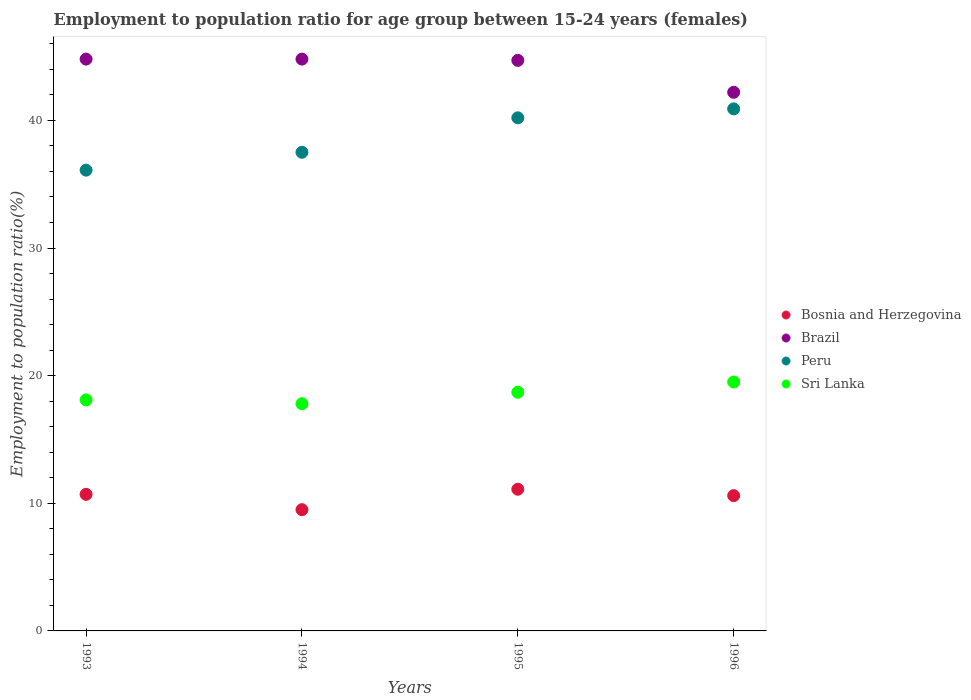What is the employment to population ratio in Sri Lanka in 1994?
Your answer should be compact. 17.8. Across all years, what is the maximum employment to population ratio in Peru?
Keep it short and to the point. 40.9. Across all years, what is the minimum employment to population ratio in Sri Lanka?
Your answer should be very brief. 17.8. In which year was the employment to population ratio in Bosnia and Herzegovina maximum?
Your response must be concise. 1995. In which year was the employment to population ratio in Sri Lanka minimum?
Your answer should be compact. 1994. What is the total employment to population ratio in Peru in the graph?
Your answer should be compact. 154.7. What is the difference between the employment to population ratio in Brazil in 1994 and that in 1995?
Ensure brevity in your answer.  0.1. What is the average employment to population ratio in Brazil per year?
Give a very brief answer. 44.12. In the year 1993, what is the difference between the employment to population ratio in Bosnia and Herzegovina and employment to population ratio in Peru?
Give a very brief answer. -25.4. In how many years, is the employment to population ratio in Peru greater than 42 %?
Keep it short and to the point. 0. What is the ratio of the employment to population ratio in Peru in 1993 to that in 1996?
Give a very brief answer. 0.88. Is the difference between the employment to population ratio in Bosnia and Herzegovina in 1993 and 1996 greater than the difference between the employment to population ratio in Peru in 1993 and 1996?
Give a very brief answer. Yes. What is the difference between the highest and the second highest employment to population ratio in Peru?
Keep it short and to the point. 0.7. What is the difference between the highest and the lowest employment to population ratio in Sri Lanka?
Offer a terse response. 1.7. Is the sum of the employment to population ratio in Peru in 1993 and 1994 greater than the maximum employment to population ratio in Brazil across all years?
Offer a terse response. Yes. Is it the case that in every year, the sum of the employment to population ratio in Bosnia and Herzegovina and employment to population ratio in Peru  is greater than the sum of employment to population ratio in Brazil and employment to population ratio in Sri Lanka?
Offer a terse response. No. Does the employment to population ratio in Sri Lanka monotonically increase over the years?
Provide a short and direct response. No. Is the employment to population ratio in Brazil strictly greater than the employment to population ratio in Peru over the years?
Provide a short and direct response. Yes. Is the employment to population ratio in Bosnia and Herzegovina strictly less than the employment to population ratio in Peru over the years?
Give a very brief answer. Yes. How many dotlines are there?
Provide a short and direct response. 4. How many years are there in the graph?
Offer a terse response. 4. What is the difference between two consecutive major ticks on the Y-axis?
Make the answer very short. 10. Are the values on the major ticks of Y-axis written in scientific E-notation?
Offer a terse response. No. Does the graph contain grids?
Offer a terse response. No. Where does the legend appear in the graph?
Your answer should be compact. Center right. What is the title of the graph?
Offer a terse response. Employment to population ratio for age group between 15-24 years (females). Does "OECD members" appear as one of the legend labels in the graph?
Your answer should be very brief. No. What is the label or title of the X-axis?
Your answer should be compact. Years. What is the label or title of the Y-axis?
Give a very brief answer. Employment to population ratio(%). What is the Employment to population ratio(%) of Bosnia and Herzegovina in 1993?
Offer a very short reply. 10.7. What is the Employment to population ratio(%) in Brazil in 1993?
Give a very brief answer. 44.8. What is the Employment to population ratio(%) of Peru in 1993?
Your answer should be very brief. 36.1. What is the Employment to population ratio(%) in Sri Lanka in 1993?
Provide a succinct answer. 18.1. What is the Employment to population ratio(%) of Bosnia and Herzegovina in 1994?
Offer a very short reply. 9.5. What is the Employment to population ratio(%) of Brazil in 1994?
Offer a terse response. 44.8. What is the Employment to population ratio(%) of Peru in 1994?
Offer a very short reply. 37.5. What is the Employment to population ratio(%) of Sri Lanka in 1994?
Keep it short and to the point. 17.8. What is the Employment to population ratio(%) in Bosnia and Herzegovina in 1995?
Your answer should be very brief. 11.1. What is the Employment to population ratio(%) in Brazil in 1995?
Keep it short and to the point. 44.7. What is the Employment to population ratio(%) of Peru in 1995?
Provide a short and direct response. 40.2. What is the Employment to population ratio(%) of Sri Lanka in 1995?
Ensure brevity in your answer.  18.7. What is the Employment to population ratio(%) of Bosnia and Herzegovina in 1996?
Your response must be concise. 10.6. What is the Employment to population ratio(%) of Brazil in 1996?
Provide a short and direct response. 42.2. What is the Employment to population ratio(%) of Peru in 1996?
Ensure brevity in your answer.  40.9. Across all years, what is the maximum Employment to population ratio(%) of Bosnia and Herzegovina?
Make the answer very short. 11.1. Across all years, what is the maximum Employment to population ratio(%) of Brazil?
Your response must be concise. 44.8. Across all years, what is the maximum Employment to population ratio(%) of Peru?
Make the answer very short. 40.9. Across all years, what is the maximum Employment to population ratio(%) in Sri Lanka?
Provide a short and direct response. 19.5. Across all years, what is the minimum Employment to population ratio(%) in Bosnia and Herzegovina?
Your answer should be compact. 9.5. Across all years, what is the minimum Employment to population ratio(%) in Brazil?
Offer a terse response. 42.2. Across all years, what is the minimum Employment to population ratio(%) in Peru?
Keep it short and to the point. 36.1. Across all years, what is the minimum Employment to population ratio(%) of Sri Lanka?
Make the answer very short. 17.8. What is the total Employment to population ratio(%) in Bosnia and Herzegovina in the graph?
Provide a short and direct response. 41.9. What is the total Employment to population ratio(%) of Brazil in the graph?
Make the answer very short. 176.5. What is the total Employment to population ratio(%) in Peru in the graph?
Your response must be concise. 154.7. What is the total Employment to population ratio(%) in Sri Lanka in the graph?
Give a very brief answer. 74.1. What is the difference between the Employment to population ratio(%) in Bosnia and Herzegovina in 1993 and that in 1994?
Keep it short and to the point. 1.2. What is the difference between the Employment to population ratio(%) in Brazil in 1993 and that in 1994?
Ensure brevity in your answer.  0. What is the difference between the Employment to population ratio(%) in Peru in 1993 and that in 1994?
Your answer should be very brief. -1.4. What is the difference between the Employment to population ratio(%) in Sri Lanka in 1993 and that in 1994?
Give a very brief answer. 0.3. What is the difference between the Employment to population ratio(%) of Bosnia and Herzegovina in 1993 and that in 1995?
Your response must be concise. -0.4. What is the difference between the Employment to population ratio(%) in Brazil in 1993 and that in 1995?
Offer a terse response. 0.1. What is the difference between the Employment to population ratio(%) of Bosnia and Herzegovina in 1993 and that in 1996?
Make the answer very short. 0.1. What is the difference between the Employment to population ratio(%) in Brazil in 1993 and that in 1996?
Give a very brief answer. 2.6. What is the difference between the Employment to population ratio(%) in Sri Lanka in 1993 and that in 1996?
Your answer should be very brief. -1.4. What is the difference between the Employment to population ratio(%) of Bosnia and Herzegovina in 1994 and that in 1995?
Offer a terse response. -1.6. What is the difference between the Employment to population ratio(%) in Brazil in 1994 and that in 1995?
Provide a short and direct response. 0.1. What is the difference between the Employment to population ratio(%) of Peru in 1994 and that in 1995?
Offer a very short reply. -2.7. What is the difference between the Employment to population ratio(%) in Sri Lanka in 1994 and that in 1995?
Give a very brief answer. -0.9. What is the difference between the Employment to population ratio(%) in Bosnia and Herzegovina in 1994 and that in 1996?
Keep it short and to the point. -1.1. What is the difference between the Employment to population ratio(%) in Brazil in 1994 and that in 1996?
Provide a succinct answer. 2.6. What is the difference between the Employment to population ratio(%) of Bosnia and Herzegovina in 1995 and that in 1996?
Make the answer very short. 0.5. What is the difference between the Employment to population ratio(%) of Brazil in 1995 and that in 1996?
Give a very brief answer. 2.5. What is the difference between the Employment to population ratio(%) of Bosnia and Herzegovina in 1993 and the Employment to population ratio(%) of Brazil in 1994?
Your answer should be very brief. -34.1. What is the difference between the Employment to population ratio(%) of Bosnia and Herzegovina in 1993 and the Employment to population ratio(%) of Peru in 1994?
Your answer should be compact. -26.8. What is the difference between the Employment to population ratio(%) of Bosnia and Herzegovina in 1993 and the Employment to population ratio(%) of Sri Lanka in 1994?
Give a very brief answer. -7.1. What is the difference between the Employment to population ratio(%) of Brazil in 1993 and the Employment to population ratio(%) of Peru in 1994?
Make the answer very short. 7.3. What is the difference between the Employment to population ratio(%) in Peru in 1993 and the Employment to population ratio(%) in Sri Lanka in 1994?
Offer a very short reply. 18.3. What is the difference between the Employment to population ratio(%) of Bosnia and Herzegovina in 1993 and the Employment to population ratio(%) of Brazil in 1995?
Offer a very short reply. -34. What is the difference between the Employment to population ratio(%) of Bosnia and Herzegovina in 1993 and the Employment to population ratio(%) of Peru in 1995?
Keep it short and to the point. -29.5. What is the difference between the Employment to population ratio(%) of Brazil in 1993 and the Employment to population ratio(%) of Peru in 1995?
Give a very brief answer. 4.6. What is the difference between the Employment to population ratio(%) in Brazil in 1993 and the Employment to population ratio(%) in Sri Lanka in 1995?
Ensure brevity in your answer.  26.1. What is the difference between the Employment to population ratio(%) of Peru in 1993 and the Employment to population ratio(%) of Sri Lanka in 1995?
Offer a terse response. 17.4. What is the difference between the Employment to population ratio(%) in Bosnia and Herzegovina in 1993 and the Employment to population ratio(%) in Brazil in 1996?
Make the answer very short. -31.5. What is the difference between the Employment to population ratio(%) of Bosnia and Herzegovina in 1993 and the Employment to population ratio(%) of Peru in 1996?
Make the answer very short. -30.2. What is the difference between the Employment to population ratio(%) of Brazil in 1993 and the Employment to population ratio(%) of Peru in 1996?
Your answer should be compact. 3.9. What is the difference between the Employment to population ratio(%) of Brazil in 1993 and the Employment to population ratio(%) of Sri Lanka in 1996?
Your response must be concise. 25.3. What is the difference between the Employment to population ratio(%) in Peru in 1993 and the Employment to population ratio(%) in Sri Lanka in 1996?
Offer a terse response. 16.6. What is the difference between the Employment to population ratio(%) of Bosnia and Herzegovina in 1994 and the Employment to population ratio(%) of Brazil in 1995?
Your answer should be very brief. -35.2. What is the difference between the Employment to population ratio(%) in Bosnia and Herzegovina in 1994 and the Employment to population ratio(%) in Peru in 1995?
Make the answer very short. -30.7. What is the difference between the Employment to population ratio(%) of Bosnia and Herzegovina in 1994 and the Employment to population ratio(%) of Sri Lanka in 1995?
Offer a terse response. -9.2. What is the difference between the Employment to population ratio(%) of Brazil in 1994 and the Employment to population ratio(%) of Sri Lanka in 1995?
Ensure brevity in your answer.  26.1. What is the difference between the Employment to population ratio(%) in Bosnia and Herzegovina in 1994 and the Employment to population ratio(%) in Brazil in 1996?
Provide a short and direct response. -32.7. What is the difference between the Employment to population ratio(%) of Bosnia and Herzegovina in 1994 and the Employment to population ratio(%) of Peru in 1996?
Your response must be concise. -31.4. What is the difference between the Employment to population ratio(%) in Brazil in 1994 and the Employment to population ratio(%) in Peru in 1996?
Ensure brevity in your answer.  3.9. What is the difference between the Employment to population ratio(%) in Brazil in 1994 and the Employment to population ratio(%) in Sri Lanka in 1996?
Your response must be concise. 25.3. What is the difference between the Employment to population ratio(%) of Bosnia and Herzegovina in 1995 and the Employment to population ratio(%) of Brazil in 1996?
Your response must be concise. -31.1. What is the difference between the Employment to population ratio(%) of Bosnia and Herzegovina in 1995 and the Employment to population ratio(%) of Peru in 1996?
Offer a very short reply. -29.8. What is the difference between the Employment to population ratio(%) in Brazil in 1995 and the Employment to population ratio(%) in Peru in 1996?
Your response must be concise. 3.8. What is the difference between the Employment to population ratio(%) of Brazil in 1995 and the Employment to population ratio(%) of Sri Lanka in 1996?
Provide a succinct answer. 25.2. What is the difference between the Employment to population ratio(%) in Peru in 1995 and the Employment to population ratio(%) in Sri Lanka in 1996?
Keep it short and to the point. 20.7. What is the average Employment to population ratio(%) in Bosnia and Herzegovina per year?
Make the answer very short. 10.47. What is the average Employment to population ratio(%) of Brazil per year?
Offer a terse response. 44.12. What is the average Employment to population ratio(%) in Peru per year?
Your answer should be compact. 38.67. What is the average Employment to population ratio(%) of Sri Lanka per year?
Provide a short and direct response. 18.52. In the year 1993, what is the difference between the Employment to population ratio(%) of Bosnia and Herzegovina and Employment to population ratio(%) of Brazil?
Provide a succinct answer. -34.1. In the year 1993, what is the difference between the Employment to population ratio(%) in Bosnia and Herzegovina and Employment to population ratio(%) in Peru?
Provide a short and direct response. -25.4. In the year 1993, what is the difference between the Employment to population ratio(%) of Brazil and Employment to population ratio(%) of Sri Lanka?
Offer a very short reply. 26.7. In the year 1993, what is the difference between the Employment to population ratio(%) in Peru and Employment to population ratio(%) in Sri Lanka?
Offer a terse response. 18. In the year 1994, what is the difference between the Employment to population ratio(%) of Bosnia and Herzegovina and Employment to population ratio(%) of Brazil?
Ensure brevity in your answer.  -35.3. In the year 1994, what is the difference between the Employment to population ratio(%) of Bosnia and Herzegovina and Employment to population ratio(%) of Peru?
Make the answer very short. -28. In the year 1994, what is the difference between the Employment to population ratio(%) of Bosnia and Herzegovina and Employment to population ratio(%) of Sri Lanka?
Provide a short and direct response. -8.3. In the year 1995, what is the difference between the Employment to population ratio(%) of Bosnia and Herzegovina and Employment to population ratio(%) of Brazil?
Your answer should be compact. -33.6. In the year 1995, what is the difference between the Employment to population ratio(%) of Bosnia and Herzegovina and Employment to population ratio(%) of Peru?
Your answer should be compact. -29.1. In the year 1995, what is the difference between the Employment to population ratio(%) in Brazil and Employment to population ratio(%) in Peru?
Offer a terse response. 4.5. In the year 1996, what is the difference between the Employment to population ratio(%) in Bosnia and Herzegovina and Employment to population ratio(%) in Brazil?
Offer a very short reply. -31.6. In the year 1996, what is the difference between the Employment to population ratio(%) in Bosnia and Herzegovina and Employment to population ratio(%) in Peru?
Provide a succinct answer. -30.3. In the year 1996, what is the difference between the Employment to population ratio(%) of Brazil and Employment to population ratio(%) of Sri Lanka?
Provide a short and direct response. 22.7. In the year 1996, what is the difference between the Employment to population ratio(%) of Peru and Employment to population ratio(%) of Sri Lanka?
Offer a terse response. 21.4. What is the ratio of the Employment to population ratio(%) in Bosnia and Herzegovina in 1993 to that in 1994?
Provide a succinct answer. 1.13. What is the ratio of the Employment to population ratio(%) in Peru in 1993 to that in 1994?
Give a very brief answer. 0.96. What is the ratio of the Employment to population ratio(%) in Sri Lanka in 1993 to that in 1994?
Your answer should be very brief. 1.02. What is the ratio of the Employment to population ratio(%) of Brazil in 1993 to that in 1995?
Offer a terse response. 1. What is the ratio of the Employment to population ratio(%) in Peru in 1993 to that in 1995?
Provide a succinct answer. 0.9. What is the ratio of the Employment to population ratio(%) of Sri Lanka in 1993 to that in 1995?
Your answer should be compact. 0.97. What is the ratio of the Employment to population ratio(%) in Bosnia and Herzegovina in 1993 to that in 1996?
Keep it short and to the point. 1.01. What is the ratio of the Employment to population ratio(%) in Brazil in 1993 to that in 1996?
Provide a succinct answer. 1.06. What is the ratio of the Employment to population ratio(%) of Peru in 1993 to that in 1996?
Provide a short and direct response. 0.88. What is the ratio of the Employment to population ratio(%) of Sri Lanka in 1993 to that in 1996?
Ensure brevity in your answer.  0.93. What is the ratio of the Employment to population ratio(%) of Bosnia and Herzegovina in 1994 to that in 1995?
Your answer should be compact. 0.86. What is the ratio of the Employment to population ratio(%) of Peru in 1994 to that in 1995?
Ensure brevity in your answer.  0.93. What is the ratio of the Employment to population ratio(%) in Sri Lanka in 1994 to that in 1995?
Ensure brevity in your answer.  0.95. What is the ratio of the Employment to population ratio(%) in Bosnia and Herzegovina in 1994 to that in 1996?
Give a very brief answer. 0.9. What is the ratio of the Employment to population ratio(%) in Brazil in 1994 to that in 1996?
Ensure brevity in your answer.  1.06. What is the ratio of the Employment to population ratio(%) in Peru in 1994 to that in 1996?
Offer a terse response. 0.92. What is the ratio of the Employment to population ratio(%) in Sri Lanka in 1994 to that in 1996?
Your response must be concise. 0.91. What is the ratio of the Employment to population ratio(%) in Bosnia and Herzegovina in 1995 to that in 1996?
Make the answer very short. 1.05. What is the ratio of the Employment to population ratio(%) of Brazil in 1995 to that in 1996?
Provide a succinct answer. 1.06. What is the ratio of the Employment to population ratio(%) of Peru in 1995 to that in 1996?
Your response must be concise. 0.98. What is the difference between the highest and the second highest Employment to population ratio(%) of Brazil?
Your response must be concise. 0. What is the difference between the highest and the second highest Employment to population ratio(%) in Peru?
Provide a short and direct response. 0.7. What is the difference between the highest and the second highest Employment to population ratio(%) in Sri Lanka?
Provide a short and direct response. 0.8. What is the difference between the highest and the lowest Employment to population ratio(%) in Bosnia and Herzegovina?
Make the answer very short. 1.6. What is the difference between the highest and the lowest Employment to population ratio(%) of Brazil?
Your answer should be compact. 2.6. What is the difference between the highest and the lowest Employment to population ratio(%) of Peru?
Ensure brevity in your answer.  4.8. What is the difference between the highest and the lowest Employment to population ratio(%) of Sri Lanka?
Ensure brevity in your answer.  1.7. 